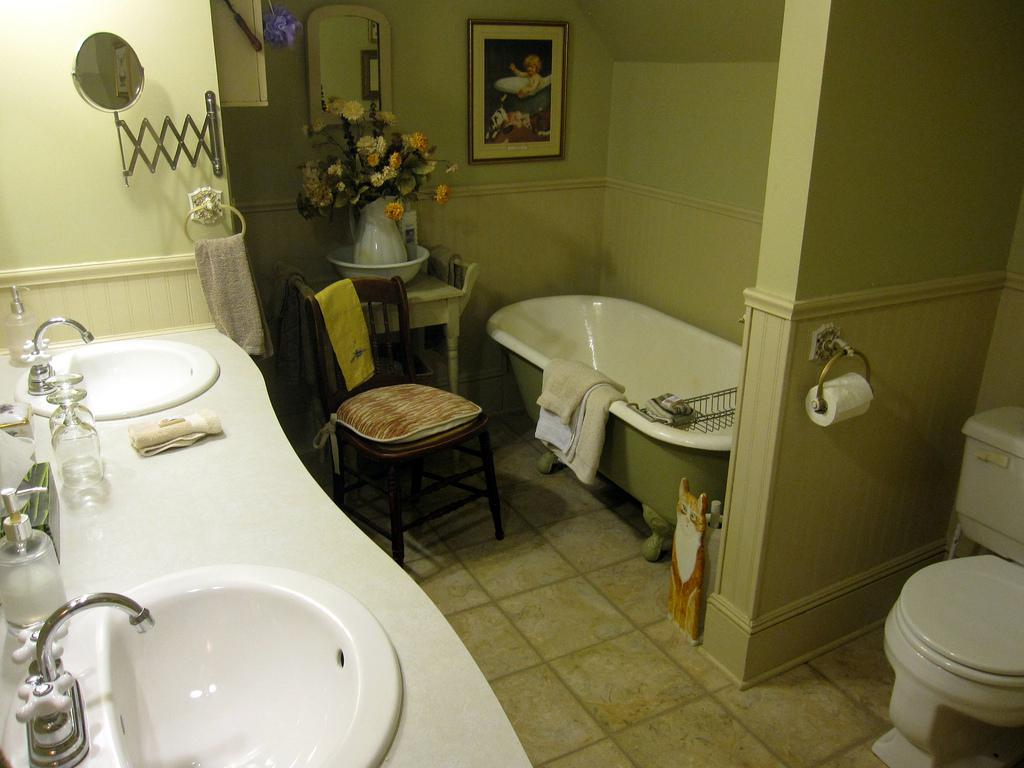Question: what is this room?
Choices:
A. A living room.
B. A kitchen.
C. A bathroom.
D. A bedroom.
Answer with the letter. Answer: C Question: who is in the bathroom?
Choices:
A. Two people.
B. Three people.
C. No one.
D. Jack.
Answer with the letter. Answer: C Question: what is on the table?
Choices:
A. A jar of coins.
B. A vase of flowers.
C. A stack of napkins.
D. Silverware.
Answer with the letter. Answer: B Question: why are there towels on the side of the tub?
Choices:
A. Because someone is going to bathe.
B. Because the tub is leaking.
C. Because the tub sometimes overflows.
D. Because the dog just took a bath.
Answer with the letter. Answer: A Question: what is to the right of the tub on the floor?
Choices:
A. A siamese cat.
B. A cat toy.
C. A statuette of a cat.
D. A wooden painted cat.
Answer with the letter. Answer: D Question: how clean and tidy is the bathroom?
Choices:
A. Sparkling.
B. Spic and span.
C. Very clean and tidy.
D. Immaculate.
Answer with the letter. Answer: C Question: what is above the bathtub?
Choices:
A. Picture.
B. Shampoo.
C. Showerhead.
D. Candle.
Answer with the letter. Answer: A Question: what finish are the faucets?
Choices:
A. Steel.
B. Bronze.
C. Chrome.
D. Gold.
Answer with the letter. Answer: C Question: where is the toilet brush?
Choices:
A. In the bathroom closet.
B. Under the bathroom sink.
C. Downstairs in the other bathroom.
D. It is hidden behind a painted cat.
Answer with the letter. Answer: D Question: where is the towel rack?
Choices:
A. Beside the sink.
B. Beside the shower.
C. On the wall.
D. Beside the toilet.
Answer with the letter. Answer: C Question: where is the soap dispenser?
Choices:
A. Sink.
B. Bathroom.
C. Counter.
D. Kitchen.
Answer with the letter. Answer: C Question: what is above the sinks?
Choices:
A. Towel rack.
B. Mirror.
C. Faucet.
D. Toothbrush.
Answer with the letter. Answer: B Question: what part of the tub has a shadow across it?
Choices:
A. The corner.
B. The back.
C. The front.
D. The middle.
Answer with the letter. Answer: A 